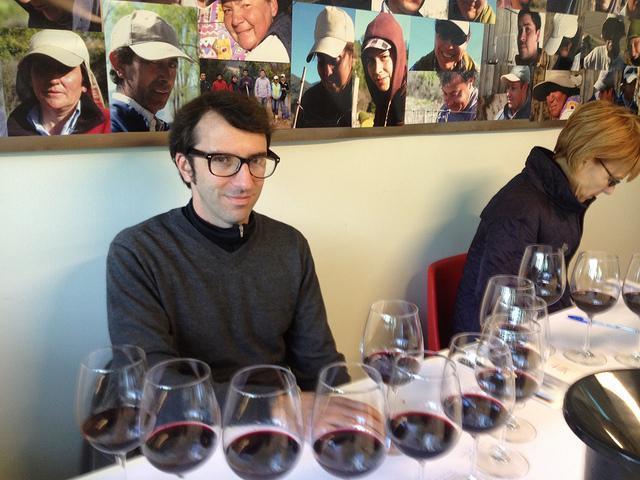How many people are in the picture?
Give a very brief answer. 2. How many real people are in the picture?
Give a very brief answer. 2. How many dining tables are in the photo?
Give a very brief answer. 1. How many wine glasses can you see?
Give a very brief answer. 11. How many people are in the photo?
Give a very brief answer. 9. 